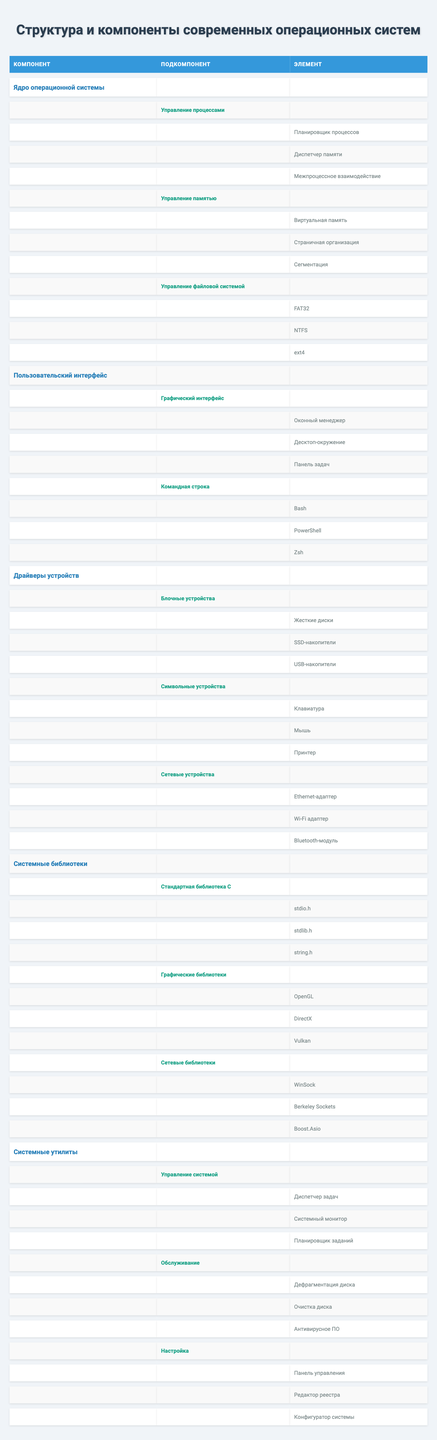What are the three main components of modern operating systems? In the table, the main components listed are "Ядро операционной системы", "Пользовательский интерфейс", and "Драйверы устройств".
Answer: Ядро операционной системы, Пользовательский интерфейс, Драйверы устройств Which user interface type includes "Bash"? The "Командная строка" under the component "Пользовательский интерфейс" includes "Bash" as one of its elements.
Answer: Командная строка Is "NTFS" part of the file system management? Yes, "NTFS" is listed under the "Управление файловой системой" subcomponent of "Ядро операционной системы".
Answer: Yes How many types of devices are mentioned in the table? In the "Драйверы устройств" section, there are three types of devices mentioned: "Блочные устройства", "Символьные устройства", and "Сетевые устройства".
Answer: 3 What component has "Виртуальная память" as an element? "Виртуальная память" is listed under the "Управление памятью" subcomponent of "Ядро операционной системы".
Answer: Ядро операционной системы Which graphical library is not included in the system libraries? There are no graphical libraries listed outside of "Системные библиотеки", so any library not under "Графические библиотеки" (OpenGL, DirectX, Vulkan) would not be included.
Answer: N/A Which system utility includes the "Диспетчер задач"? The "Диспетчер задач" is found under the "Управление системой" subcomponent in the "Системные утилиты".
Answer: Системные утилиты What is the total count of network devices listed? There are three types of network devices mentioned: "Ethernet-адаптер", "Wi-Fi адаптер", and "Bluetooth-модуль", giving us a total of three.
Answer: 3 Can you list all elements under the "Обслуживание" category? The "Обслуживание" category includes the elements: "Дефрагментация диска", "Очистка диска", and "Антивирусное ПО".
Answer: Дефрагментация диска, Очистка диска, Антивирусное ПО What subcomponent from the "Ядро операционной системы" deals with process management? The subcomponent for process management is "Управление процессами".
Answer: Управление процессами 